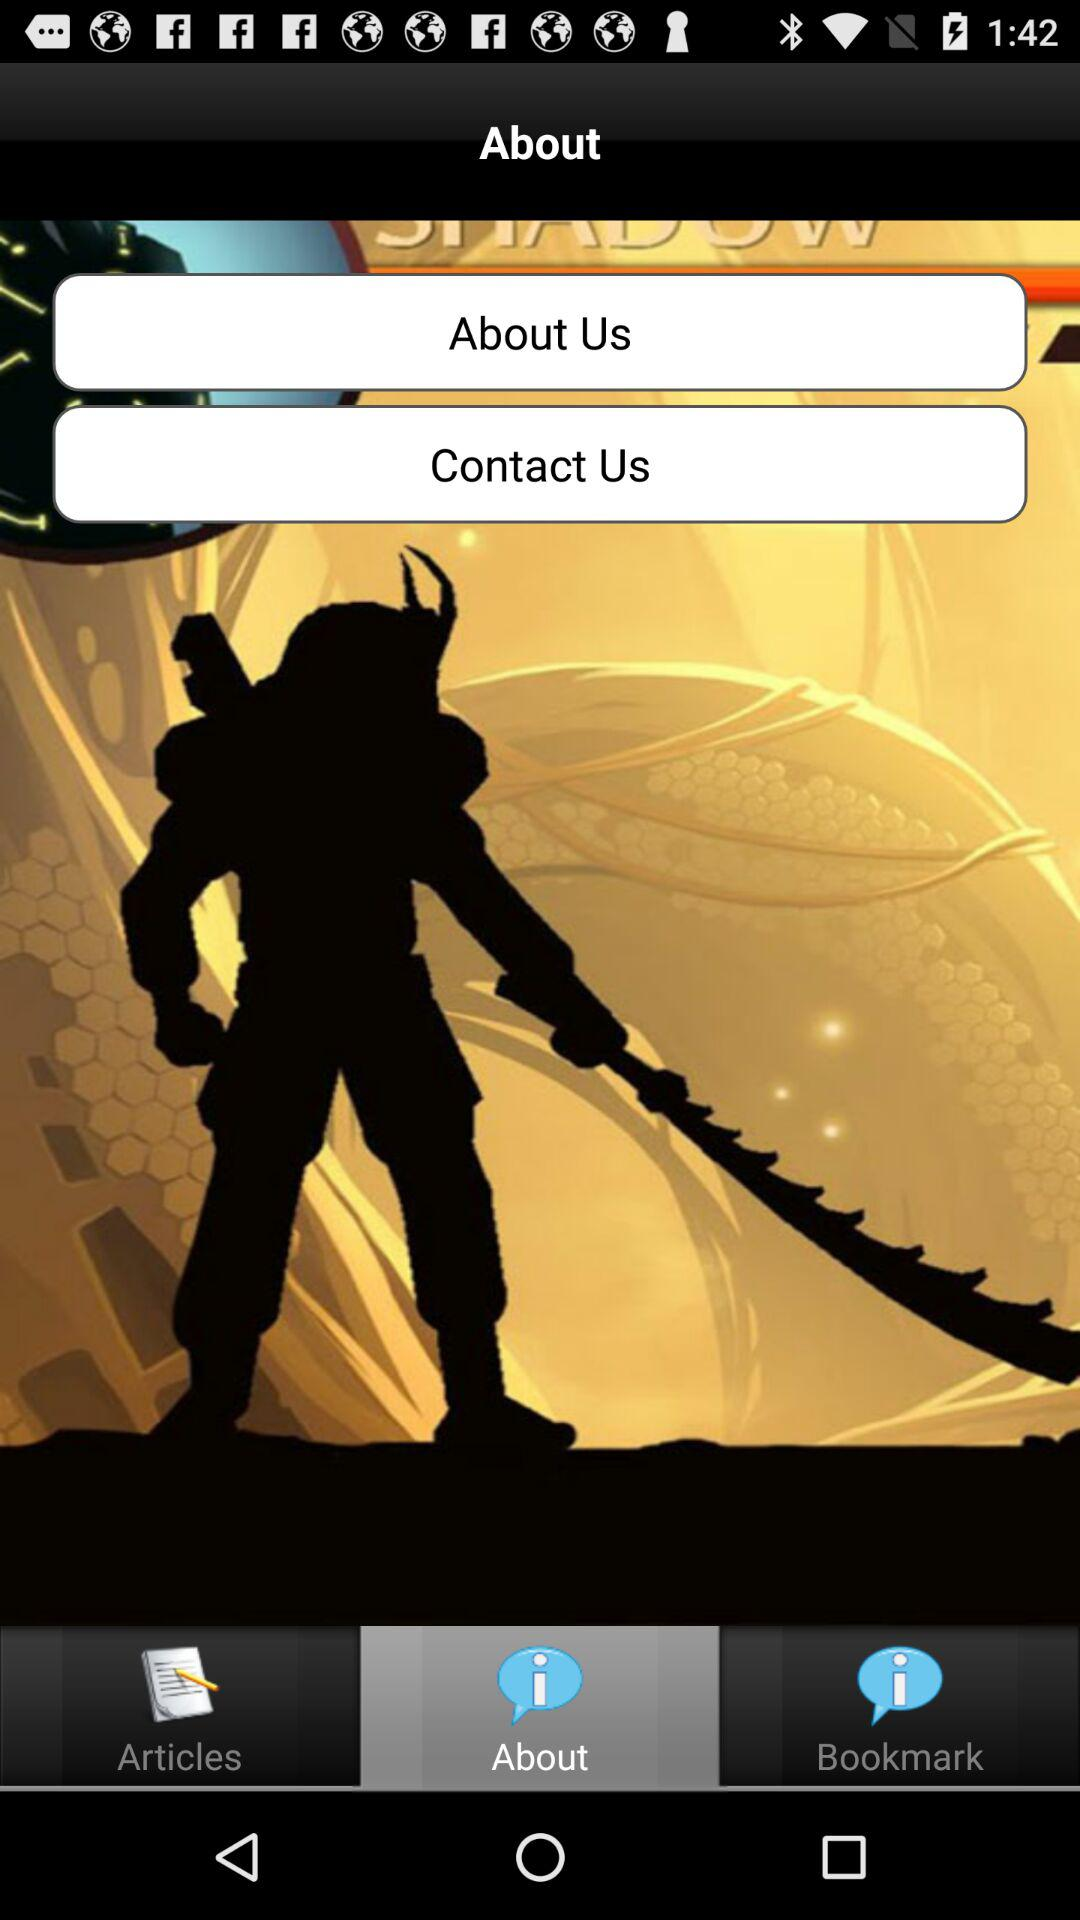What is the selected tab? The selected tab is "About". 